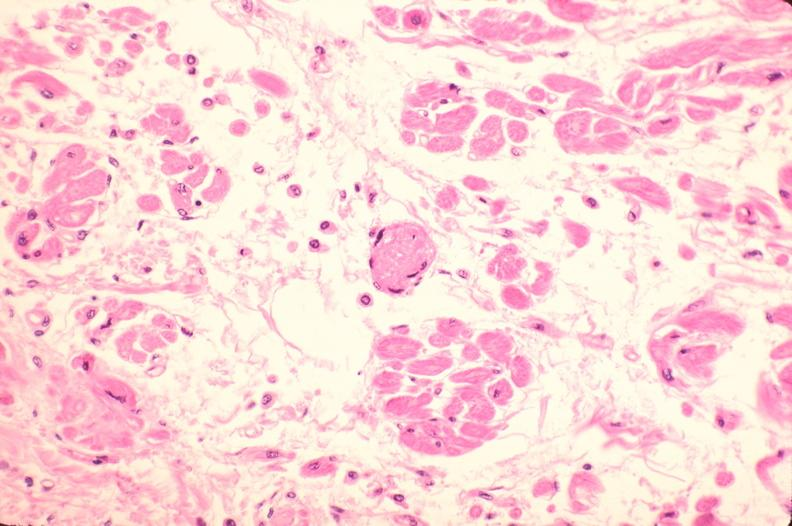what does this image show?
Answer the question using a single word or phrase. Heart 